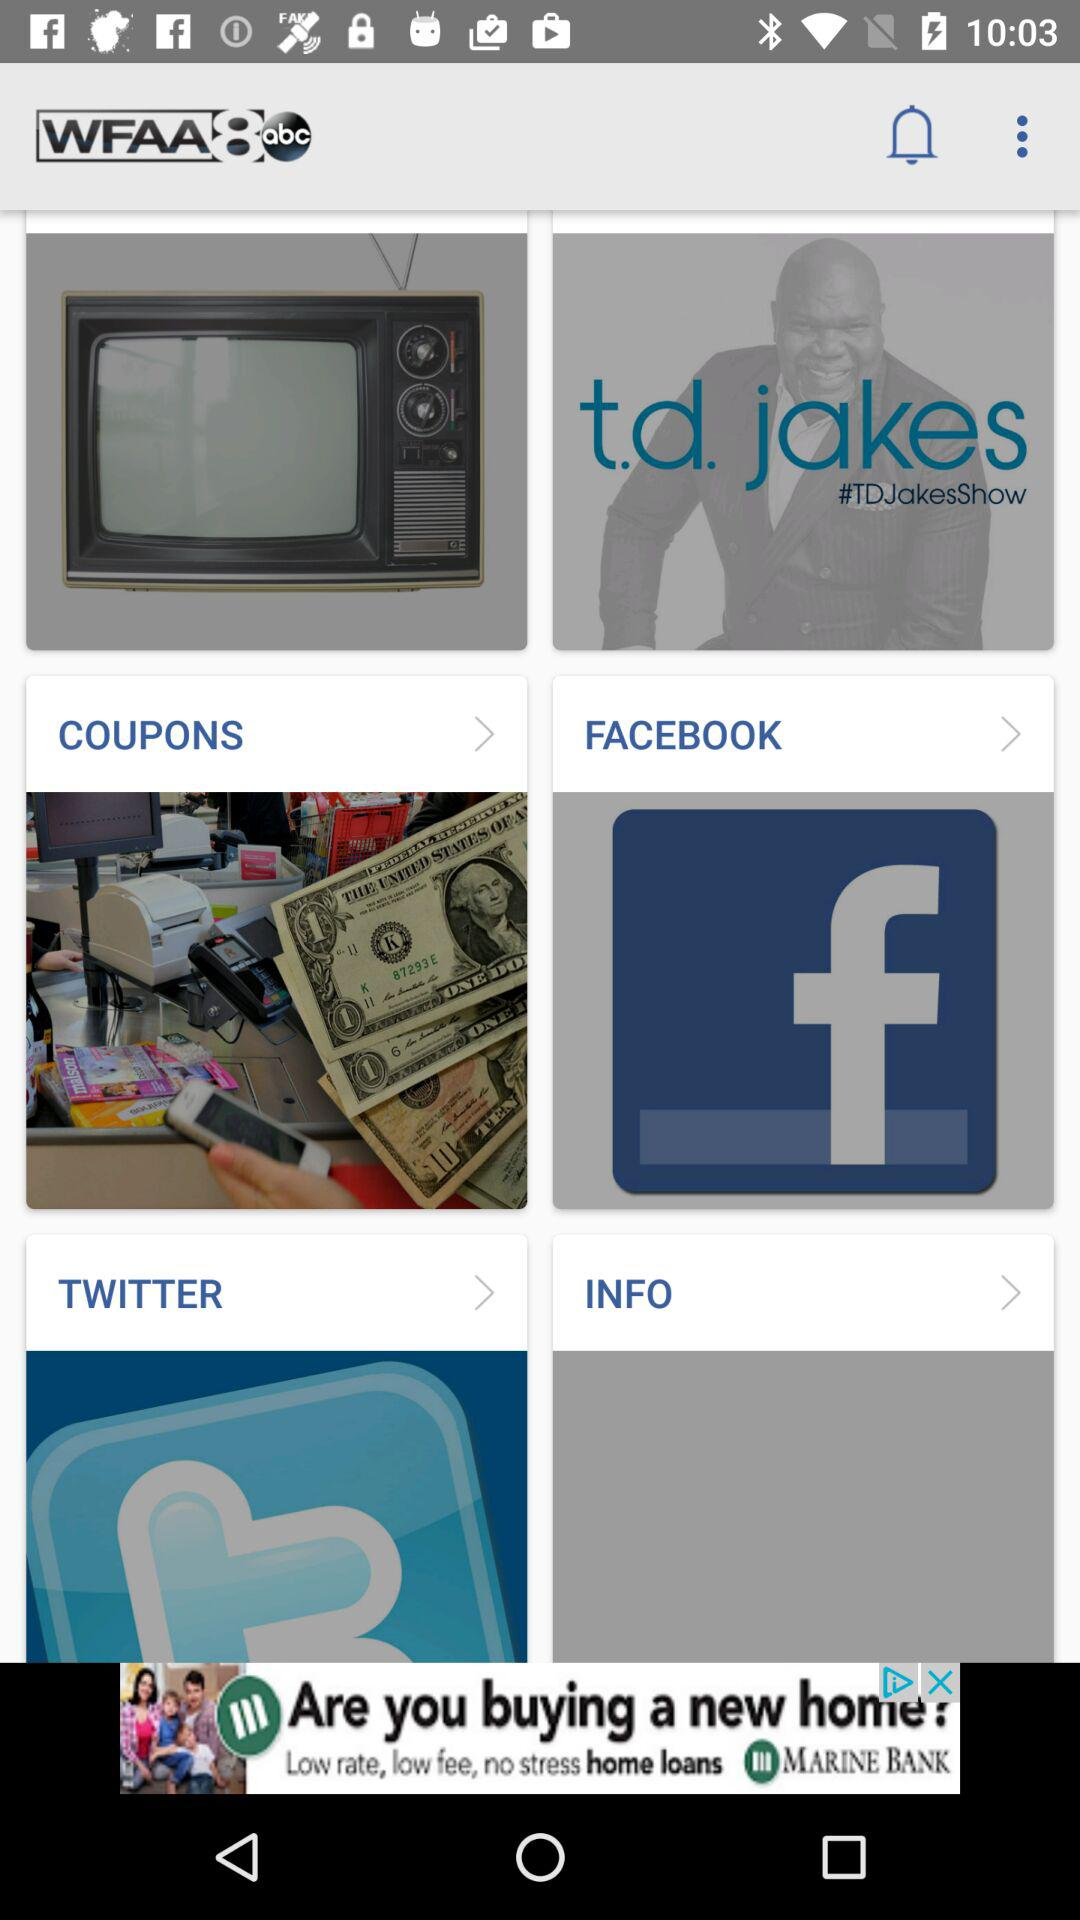Will it be rainy tomorrow?
When the provided information is insufficient, respond with <no answer>. <no answer> 